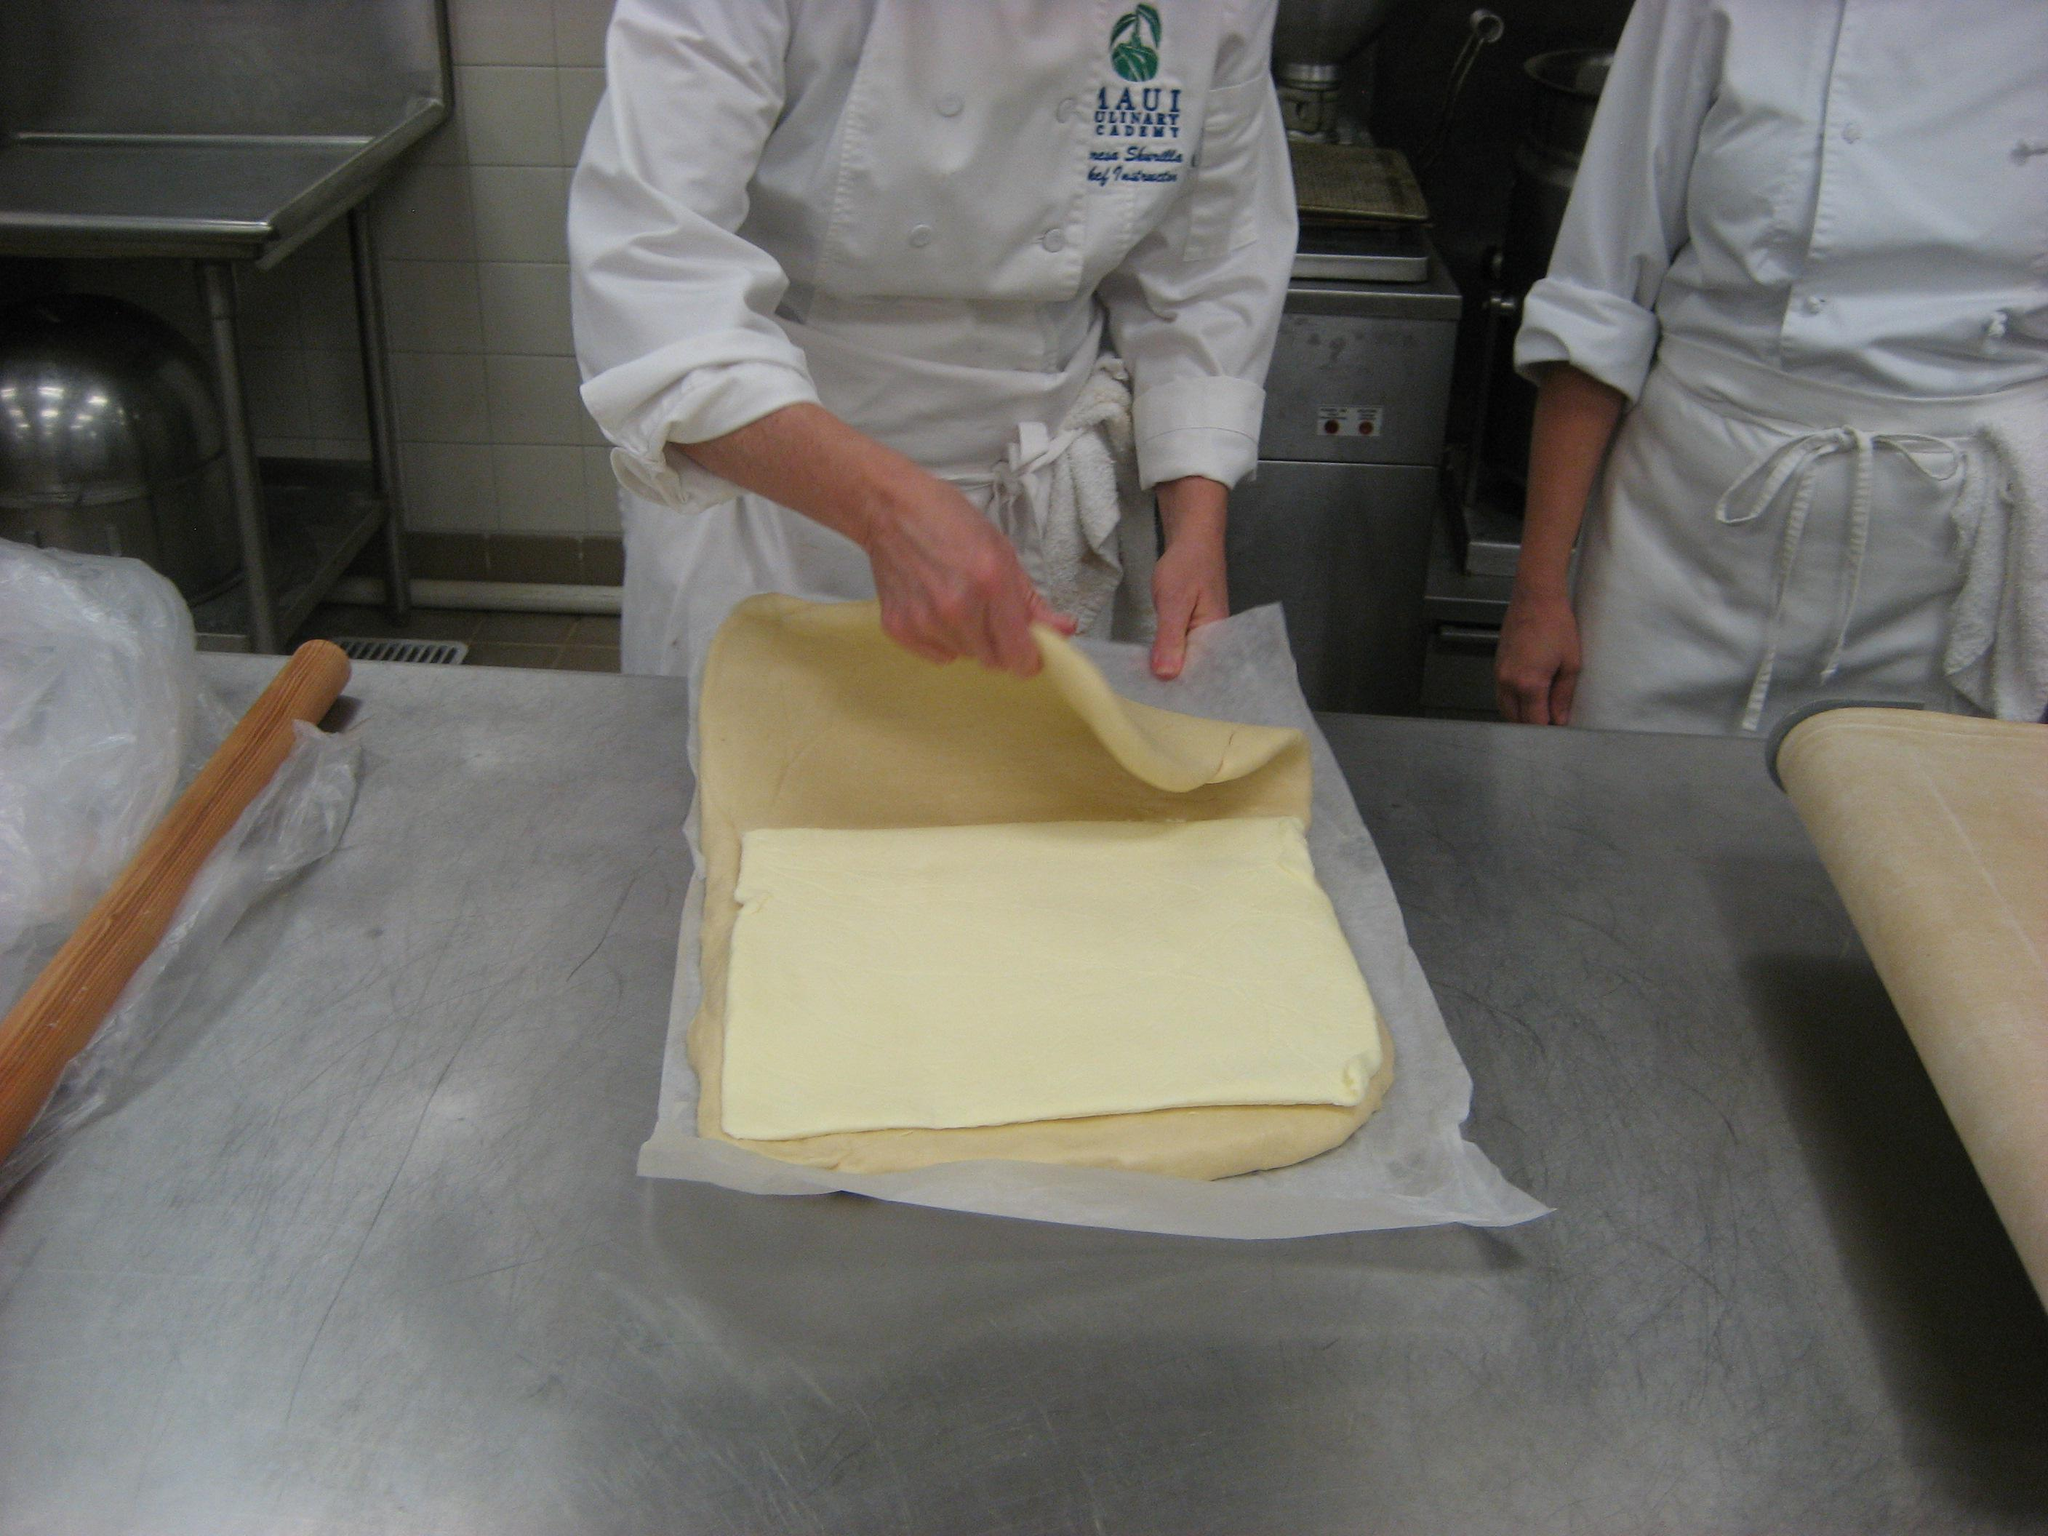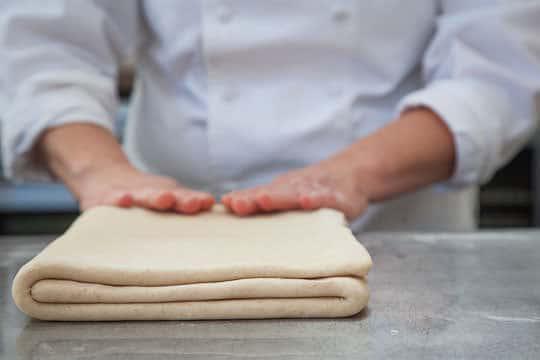The first image is the image on the left, the second image is the image on the right. Evaluate the accuracy of this statement regarding the images: "One image shows a single sheet of puff pastry with three folds visible.". Is it true? Answer yes or no. Yes. 